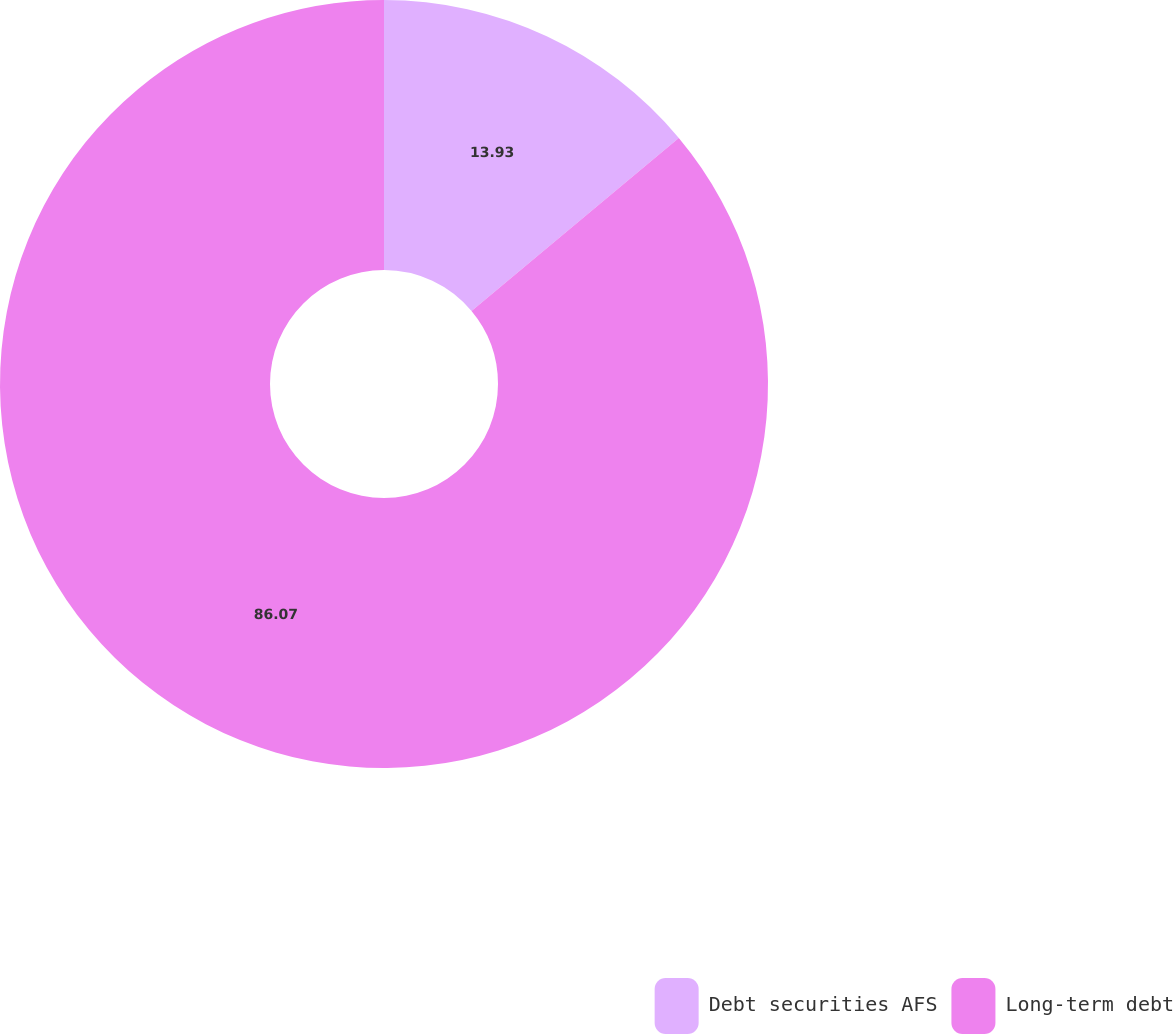Convert chart. <chart><loc_0><loc_0><loc_500><loc_500><pie_chart><fcel>Debt securities AFS<fcel>Long-term debt<nl><fcel>13.93%<fcel>86.07%<nl></chart> 